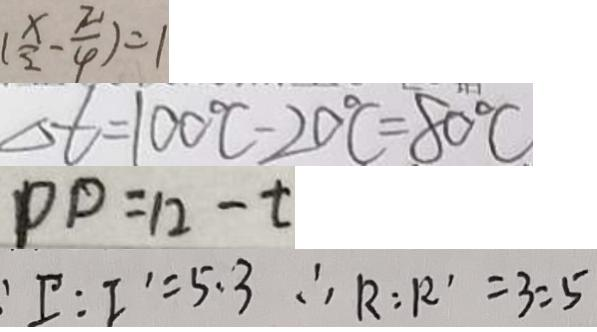Convert formula to latex. <formula><loc_0><loc_0><loc_500><loc_500>( \frac { x } { 2 } - \frac { \pi } { 4 } ) = 1 
 \Delta t = 1 0 0 ^ { \circ } C - 2 0 ^ { \circ } C = 8 0 ^ { \circ } C 
 p p = 1 2 - t 
 : I : I ^ { \prime } = 5 . 3 \therefore R : R ^ { \prime } = 3 : 5</formula> 